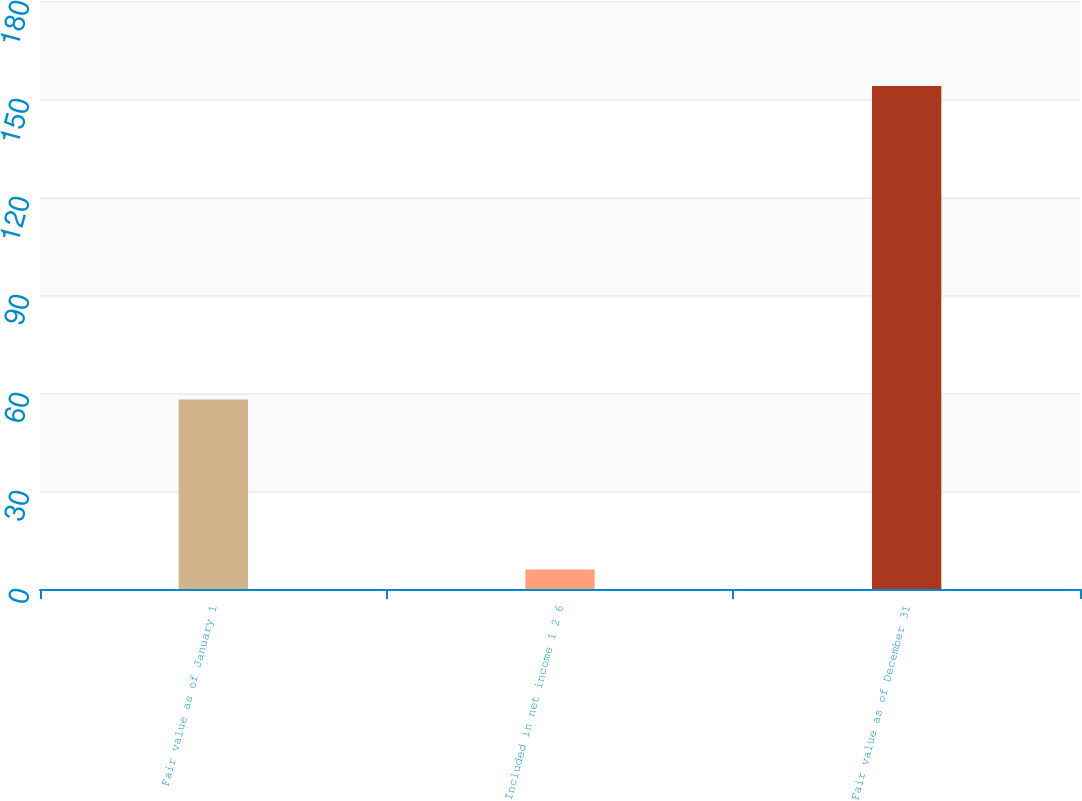Convert chart to OTSL. <chart><loc_0><loc_0><loc_500><loc_500><bar_chart><fcel>Fair value as of January 1<fcel>Included in net income 1 2 6<fcel>Fair value as of December 31<nl><fcel>58<fcel>6<fcel>154<nl></chart> 